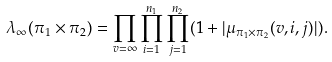Convert formula to latex. <formula><loc_0><loc_0><loc_500><loc_500>\lambda _ { \infty } ( \pi _ { 1 } \times \pi _ { 2 } ) = \prod _ { v = \infty } \prod _ { i = 1 } ^ { n _ { 1 } } \prod _ { j = 1 } ^ { n _ { 2 } } ( 1 + | \mu _ { \pi _ { 1 } \times \pi _ { 2 } } ( v , i , j ) | ) .</formula> 